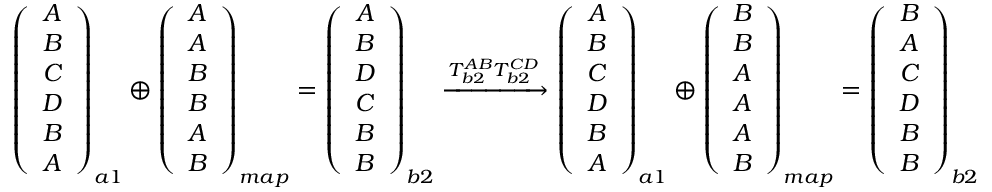Convert formula to latex. <formula><loc_0><loc_0><loc_500><loc_500>\begin{array} { r } { \left ( \begin{array} { c } { A } \\ { B } \\ { C } \\ { D } \\ { B } \\ { A } \end{array} \right ) _ { a 1 } \oplus \left ( \begin{array} { c } { A } \\ { A } \\ { B } \\ { B } \\ { A } \\ { B } \end{array} \right ) _ { m a p } = \left ( \begin{array} { c } { A } \\ { B } \\ { D } \\ { C } \\ { B } \\ { B } \end{array} \right ) _ { b 2 } \xrightarrow [ ] { T _ { b 2 } ^ { A B } T _ { b 2 } ^ { C D } } \left ( \begin{array} { c } { A } \\ { B } \\ { C } \\ { D } \\ { B } \\ { A } \end{array} \right ) _ { a 1 } \oplus \left ( \begin{array} { c } { B } \\ { B } \\ { A } \\ { A } \\ { A } \\ { B } \end{array} \right ) _ { m a p } = \left ( \begin{array} { c } { B } \\ { A } \\ { C } \\ { D } \\ { B } \\ { B } \end{array} \right ) _ { b 2 } } \end{array}</formula> 